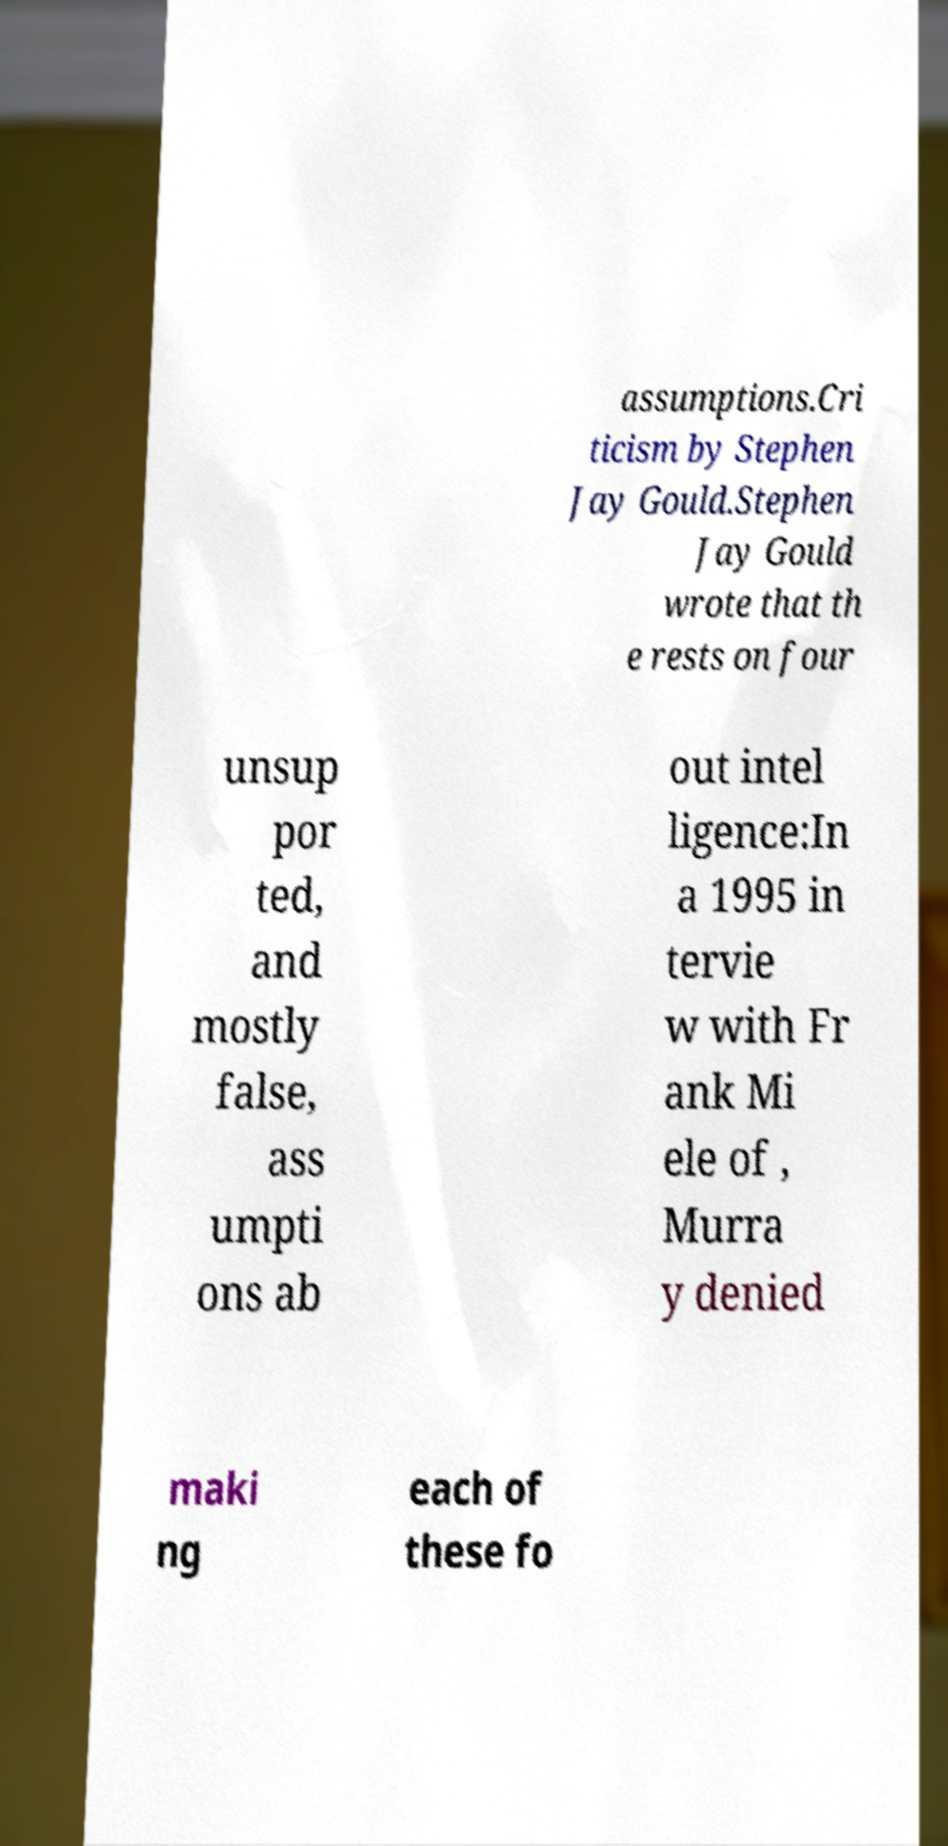Please identify and transcribe the text found in this image. assumptions.Cri ticism by Stephen Jay Gould.Stephen Jay Gould wrote that th e rests on four unsup por ted, and mostly false, ass umpti ons ab out intel ligence:In a 1995 in tervie w with Fr ank Mi ele of , Murra y denied maki ng each of these fo 